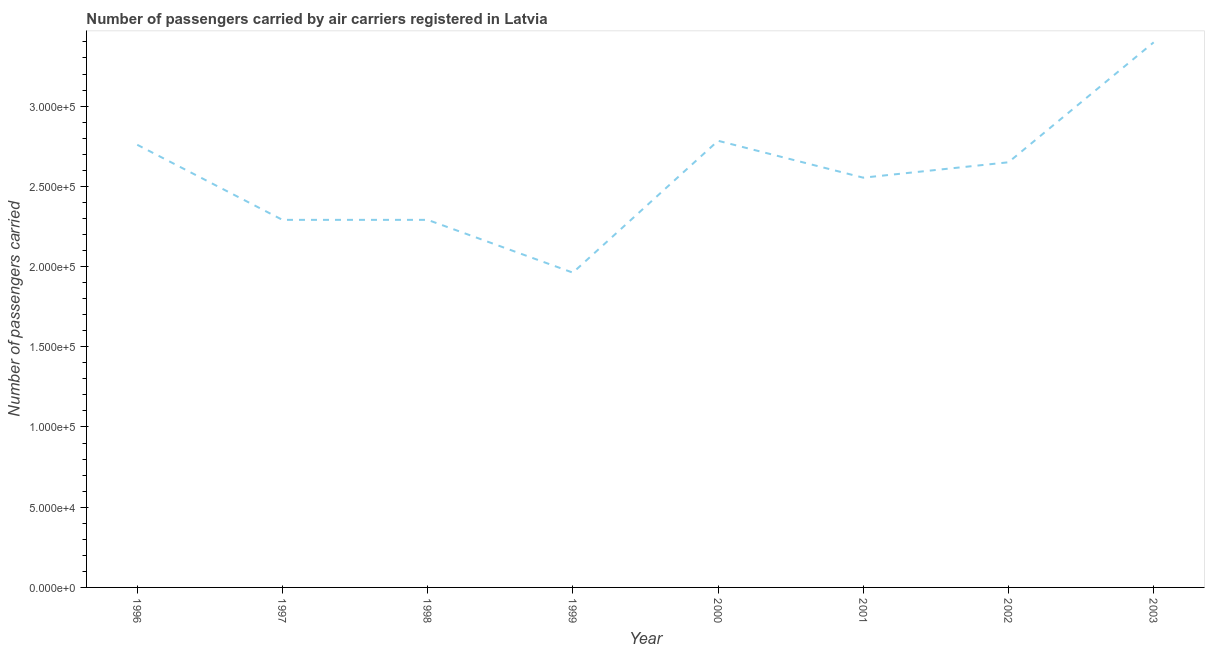What is the number of passengers carried in 2002?
Offer a very short reply. 2.65e+05. Across all years, what is the maximum number of passengers carried?
Your answer should be very brief. 3.40e+05. Across all years, what is the minimum number of passengers carried?
Keep it short and to the point. 1.96e+05. In which year was the number of passengers carried maximum?
Offer a very short reply. 2003. In which year was the number of passengers carried minimum?
Make the answer very short. 1999. What is the sum of the number of passengers carried?
Your response must be concise. 2.07e+06. What is the difference between the number of passengers carried in 1998 and 2000?
Ensure brevity in your answer.  -4.93e+04. What is the average number of passengers carried per year?
Ensure brevity in your answer.  2.59e+05. What is the median number of passengers carried?
Offer a very short reply. 2.60e+05. Do a majority of the years between 1999 and 1996 (inclusive) have number of passengers carried greater than 30000 ?
Offer a terse response. Yes. What is the ratio of the number of passengers carried in 1997 to that in 2001?
Provide a succinct answer. 0.9. Is the difference between the number of passengers carried in 1996 and 2002 greater than the difference between any two years?
Give a very brief answer. No. What is the difference between the highest and the second highest number of passengers carried?
Offer a terse response. 6.14e+04. Is the sum of the number of passengers carried in 1996 and 1999 greater than the maximum number of passengers carried across all years?
Offer a very short reply. Yes. What is the difference between the highest and the lowest number of passengers carried?
Give a very brief answer. 1.44e+05. How many years are there in the graph?
Keep it short and to the point. 8. What is the difference between two consecutive major ticks on the Y-axis?
Give a very brief answer. 5.00e+04. Are the values on the major ticks of Y-axis written in scientific E-notation?
Your response must be concise. Yes. Does the graph contain any zero values?
Your response must be concise. No. Does the graph contain grids?
Give a very brief answer. No. What is the title of the graph?
Ensure brevity in your answer.  Number of passengers carried by air carriers registered in Latvia. What is the label or title of the X-axis?
Offer a very short reply. Year. What is the label or title of the Y-axis?
Your answer should be very brief. Number of passengers carried. What is the Number of passengers carried in 1996?
Keep it short and to the point. 2.76e+05. What is the Number of passengers carried in 1997?
Keep it short and to the point. 2.29e+05. What is the Number of passengers carried of 1998?
Your answer should be very brief. 2.29e+05. What is the Number of passengers carried of 1999?
Make the answer very short. 1.96e+05. What is the Number of passengers carried in 2000?
Provide a succinct answer. 2.78e+05. What is the Number of passengers carried in 2001?
Offer a terse response. 2.55e+05. What is the Number of passengers carried of 2002?
Make the answer very short. 2.65e+05. What is the Number of passengers carried in 2003?
Ensure brevity in your answer.  3.40e+05. What is the difference between the Number of passengers carried in 1996 and 1997?
Ensure brevity in your answer.  4.68e+04. What is the difference between the Number of passengers carried in 1996 and 1998?
Your answer should be very brief. 4.68e+04. What is the difference between the Number of passengers carried in 1996 and 1999?
Provide a succinct answer. 7.97e+04. What is the difference between the Number of passengers carried in 1996 and 2000?
Give a very brief answer. -2496. What is the difference between the Number of passengers carried in 1996 and 2001?
Offer a terse response. 2.05e+04. What is the difference between the Number of passengers carried in 1996 and 2002?
Provide a short and direct response. 1.09e+04. What is the difference between the Number of passengers carried in 1996 and 2003?
Ensure brevity in your answer.  -6.38e+04. What is the difference between the Number of passengers carried in 1997 and 1998?
Ensure brevity in your answer.  0. What is the difference between the Number of passengers carried in 1997 and 1999?
Your answer should be very brief. 3.29e+04. What is the difference between the Number of passengers carried in 1997 and 2000?
Keep it short and to the point. -4.93e+04. What is the difference between the Number of passengers carried in 1997 and 2001?
Keep it short and to the point. -2.63e+04. What is the difference between the Number of passengers carried in 1997 and 2002?
Make the answer very short. -3.59e+04. What is the difference between the Number of passengers carried in 1997 and 2003?
Keep it short and to the point. -1.11e+05. What is the difference between the Number of passengers carried in 1998 and 1999?
Provide a succinct answer. 3.29e+04. What is the difference between the Number of passengers carried in 1998 and 2000?
Your response must be concise. -4.93e+04. What is the difference between the Number of passengers carried in 1998 and 2001?
Your answer should be very brief. -2.63e+04. What is the difference between the Number of passengers carried in 1998 and 2002?
Provide a succinct answer. -3.59e+04. What is the difference between the Number of passengers carried in 1998 and 2003?
Give a very brief answer. -1.11e+05. What is the difference between the Number of passengers carried in 1999 and 2000?
Provide a short and direct response. -8.22e+04. What is the difference between the Number of passengers carried in 1999 and 2001?
Your answer should be compact. -5.92e+04. What is the difference between the Number of passengers carried in 1999 and 2002?
Make the answer very short. -6.88e+04. What is the difference between the Number of passengers carried in 1999 and 2003?
Ensure brevity in your answer.  -1.44e+05. What is the difference between the Number of passengers carried in 2000 and 2001?
Provide a succinct answer. 2.30e+04. What is the difference between the Number of passengers carried in 2000 and 2002?
Give a very brief answer. 1.34e+04. What is the difference between the Number of passengers carried in 2000 and 2003?
Give a very brief answer. -6.14e+04. What is the difference between the Number of passengers carried in 2001 and 2002?
Ensure brevity in your answer.  -9599. What is the difference between the Number of passengers carried in 2001 and 2003?
Your response must be concise. -8.44e+04. What is the difference between the Number of passengers carried in 2002 and 2003?
Ensure brevity in your answer.  -7.48e+04. What is the ratio of the Number of passengers carried in 1996 to that in 1997?
Offer a terse response. 1.2. What is the ratio of the Number of passengers carried in 1996 to that in 1998?
Provide a short and direct response. 1.2. What is the ratio of the Number of passengers carried in 1996 to that in 1999?
Ensure brevity in your answer.  1.41. What is the ratio of the Number of passengers carried in 1996 to that in 2002?
Provide a succinct answer. 1.04. What is the ratio of the Number of passengers carried in 1996 to that in 2003?
Make the answer very short. 0.81. What is the ratio of the Number of passengers carried in 1997 to that in 1998?
Give a very brief answer. 1. What is the ratio of the Number of passengers carried in 1997 to that in 1999?
Offer a very short reply. 1.17. What is the ratio of the Number of passengers carried in 1997 to that in 2000?
Give a very brief answer. 0.82. What is the ratio of the Number of passengers carried in 1997 to that in 2001?
Provide a short and direct response. 0.9. What is the ratio of the Number of passengers carried in 1997 to that in 2002?
Ensure brevity in your answer.  0.86. What is the ratio of the Number of passengers carried in 1997 to that in 2003?
Make the answer very short. 0.67. What is the ratio of the Number of passengers carried in 1998 to that in 1999?
Your answer should be compact. 1.17. What is the ratio of the Number of passengers carried in 1998 to that in 2000?
Make the answer very short. 0.82. What is the ratio of the Number of passengers carried in 1998 to that in 2001?
Keep it short and to the point. 0.9. What is the ratio of the Number of passengers carried in 1998 to that in 2002?
Ensure brevity in your answer.  0.86. What is the ratio of the Number of passengers carried in 1998 to that in 2003?
Your answer should be very brief. 0.67. What is the ratio of the Number of passengers carried in 1999 to that in 2000?
Keep it short and to the point. 0.7. What is the ratio of the Number of passengers carried in 1999 to that in 2001?
Provide a short and direct response. 0.77. What is the ratio of the Number of passengers carried in 1999 to that in 2002?
Provide a short and direct response. 0.74. What is the ratio of the Number of passengers carried in 1999 to that in 2003?
Give a very brief answer. 0.58. What is the ratio of the Number of passengers carried in 2000 to that in 2001?
Offer a very short reply. 1.09. What is the ratio of the Number of passengers carried in 2000 to that in 2002?
Provide a short and direct response. 1.05. What is the ratio of the Number of passengers carried in 2000 to that in 2003?
Your response must be concise. 0.82. What is the ratio of the Number of passengers carried in 2001 to that in 2002?
Give a very brief answer. 0.96. What is the ratio of the Number of passengers carried in 2001 to that in 2003?
Ensure brevity in your answer.  0.75. What is the ratio of the Number of passengers carried in 2002 to that in 2003?
Your answer should be very brief. 0.78. 